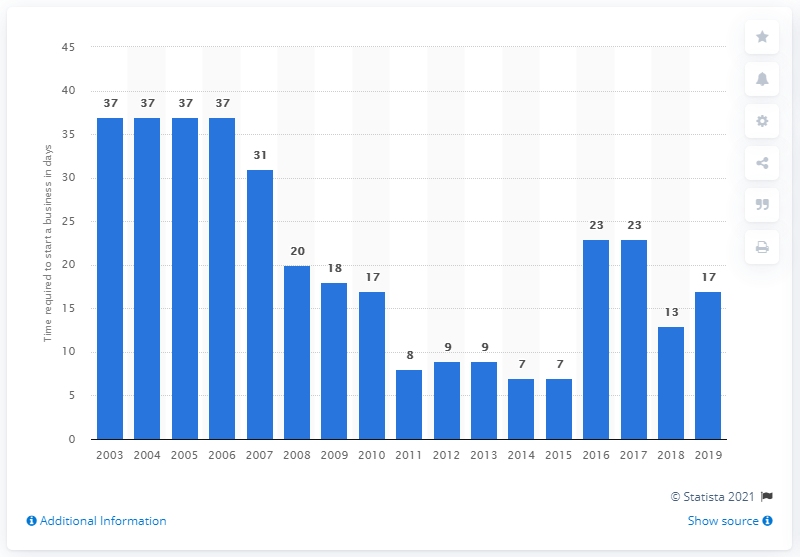Specify some key components in this picture. It took an average of 17 days for men in Malaysia to start a business. 